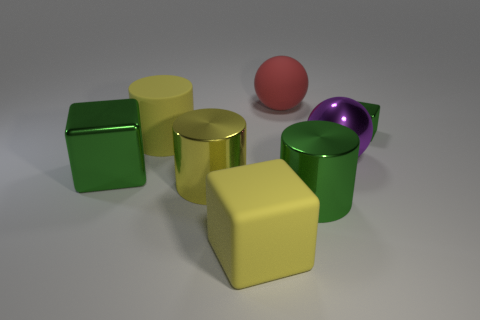Subtract all tiny blocks. How many blocks are left? 2 Subtract all red cylinders. How many green blocks are left? 2 Add 1 large red spheres. How many objects exist? 9 Subtract all yellow blocks. How many blocks are left? 2 Subtract all blocks. How many objects are left? 5 Subtract all gray cylinders. Subtract all yellow blocks. How many cylinders are left? 3 Add 4 cubes. How many cubes exist? 7 Subtract 1 yellow blocks. How many objects are left? 7 Subtract all matte things. Subtract all big cubes. How many objects are left? 3 Add 1 small cubes. How many small cubes are left? 2 